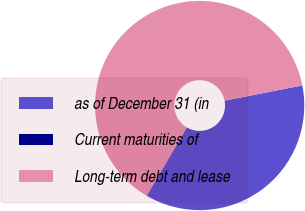<chart> <loc_0><loc_0><loc_500><loc_500><pie_chart><fcel>as of December 31 (in<fcel>Current maturities of<fcel>Long-term debt and lease<nl><fcel>36.48%<fcel>0.05%<fcel>63.47%<nl></chart> 